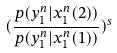Convert formula to latex. <formula><loc_0><loc_0><loc_500><loc_500>( \frac { p ( y _ { 1 } ^ { n } | x _ { 1 } ^ { n } ( 2 ) ) } { p ( y _ { 1 } ^ { n } | x _ { 1 } ^ { n } ( 1 ) ) } ) ^ { s }</formula> 